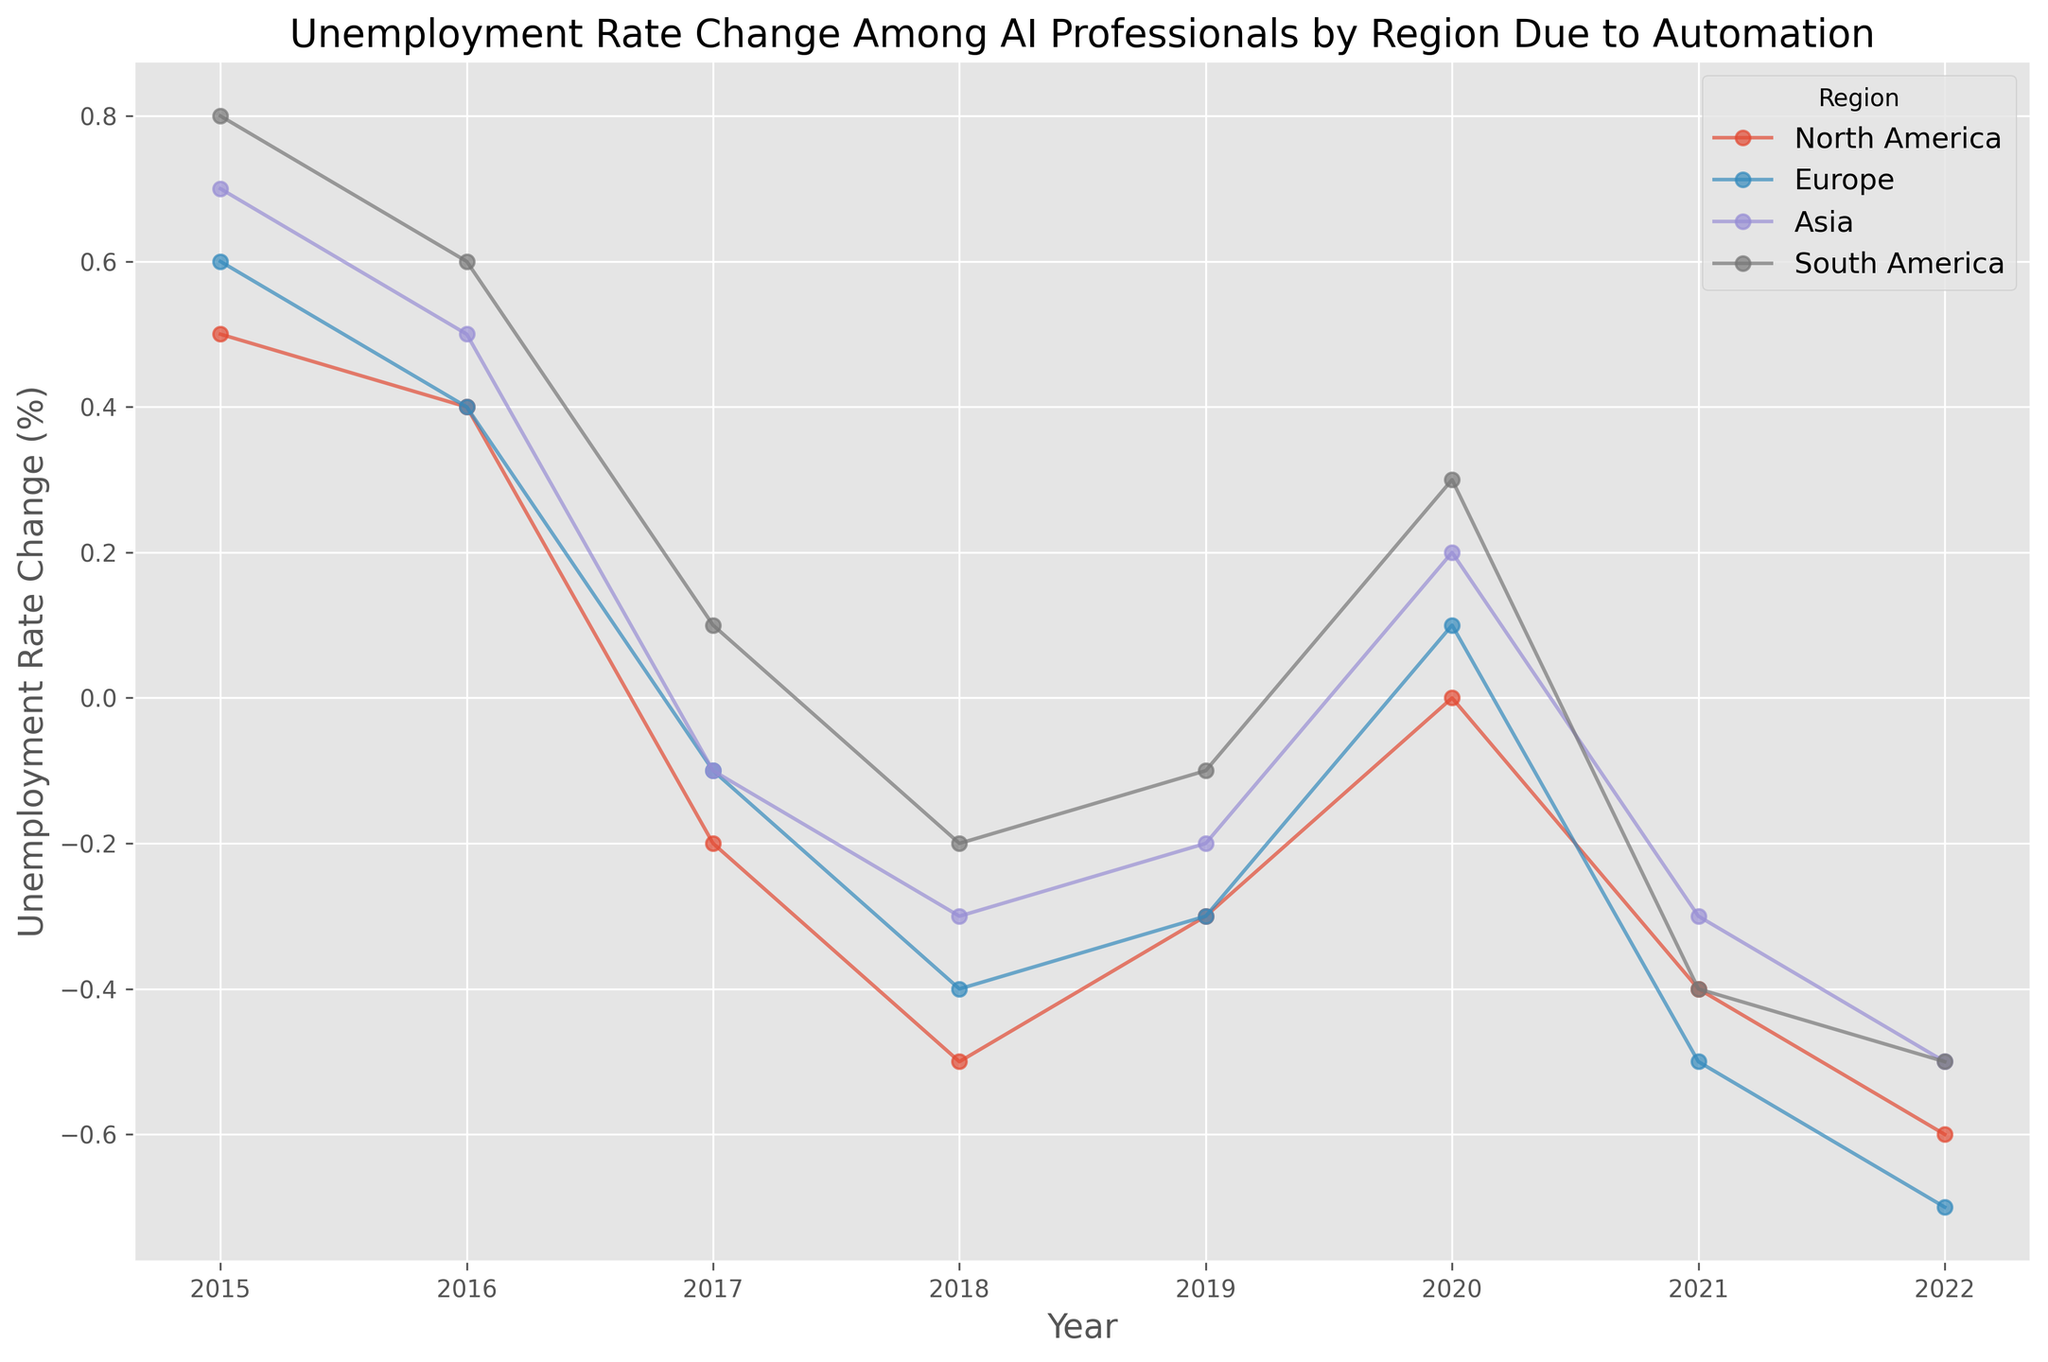Which region had the highest positive unemployment rate change in 2015? Look at the data points for 2015 across all regions and identify the highest value. North America had 0.5, Europe had 0.6, Asia had 0.7, and South America had 0.8. South America has the highest positive rate.
Answer: South America Comparing 2021 to 2022, which region saw the largest decrease in unemployment rate? To find the largest decrease in unemployment rate change, subtract the 2022 value from the 2021 value for each region. North America: -0.6 - (-0.4) = -0.2, Europe: -0.7 - (-0.5) = -0.2, Asia: -0.5 - (-0.3) = -0.2, South America: -0.5 - (-0.4) = -0.1. North America, Europe, and Asia all had the largest decrease of -0.2.
Answer: North America, Europe, and Asia What was the trend of unemployment rate change in North America from 2015 to 2022? Look at the plot line for North America from 2015 to 2022. The rate change was positive in 2015 and 2016, negative or zero in the following years (2017 to 2022), with the biggest negative rate in 2022.
Answer: Decreasing trend overall Which region experienced the most fluctuating unemployment rate change over the years? Compare the variance of unemployment rate changes in each region's plot line. The region with higher variances and changes in direction most frequently is considered. South America has varied from 0.8 to 0.6, 0.1, -0.2, -0.1, 0.3, -0.4, and -0.5, showing the highest fluctuation.
Answer: South America How does the unemployment rate change in Europe in 2020 compare to that in Asia in 2020? Look at the unemployment rate change for 2020 in both Europe and Asia. Europe has a rate change of 0.1 and Asia has 0.2. Compare these values.
Answer: Asia had a higher rate change What was the average unemployment rate change in Europe from 2015 to 2022? Sum the unemployment rate changes from 2015 to 2022 in Europe and divide by the number of years. Summing up (0.6 + 0.4 - 0.1 - 0.4 - 0.3 + 0.1 - 0.5 - 0.7) = -0.9, the average is -0.9/8 = -0.1125.
Answer: -0.1125 Between 2015 and 2019, which region had the most consistent decrease in unemployment rate change? Compare the unemployment rate changes from 2015 to 2019 for each region and see which had consistently decreasing values. North America had consistent decreases after 2017, Europe after 2016, Asia mostly decreased except 2019, South America had positive and negative changes. Europe had the most consistent decrease.
Answer: Europe During which year did North America experience no change in the unemployment rate? Look for the year in the plot line of North America where the rate change is 0.0. In 2020, North America had a rate change of 0.0.
Answer: 2020 